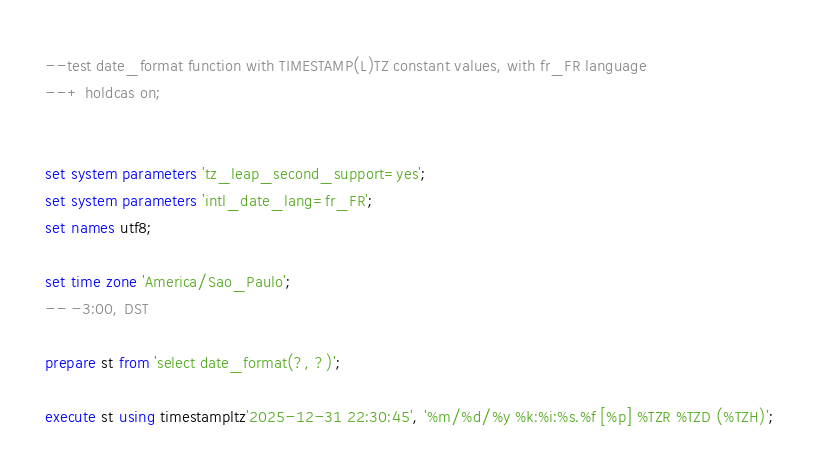Convert code to text. <code><loc_0><loc_0><loc_500><loc_500><_SQL_>--test date_format function with TIMESTAMP(L)TZ constant values, with fr_FR language
--+ holdcas on;


set system parameters 'tz_leap_second_support=yes';
set system parameters 'intl_date_lang=fr_FR';
set names utf8;

set time zone 'America/Sao_Paulo';
-- -3:00, DST

prepare st from 'select date_format(?, ?)';

execute st using timestampltz'2025-12-31 22:30:45', '%m/%d/%y %k:%i:%s.%f [%p] %TZR %TZD (%TZH)';</code> 